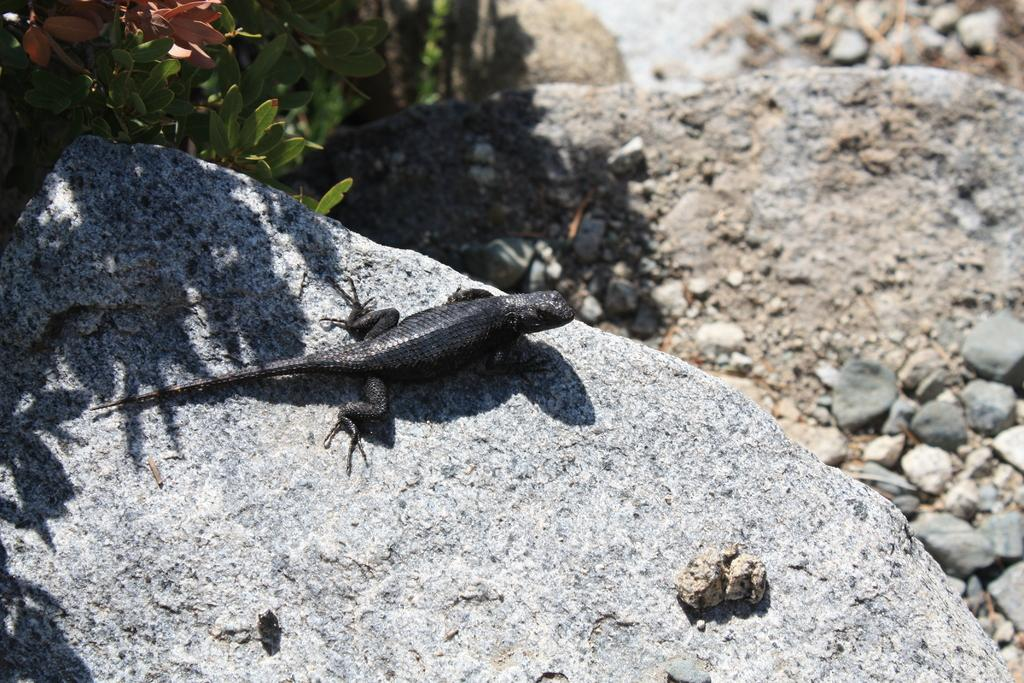What type of animal is in the image? There is a reptile in the image. Where is the reptile located? The reptile is on a rock. What is the color of the reptile? The reptile is black in color. What can be seen on the right side of the image? There are stones on the right side of the image. What type of vegetation is on the left side of the image? There are plants on the left side of the image. What advice does the reptile's aunt give during their discussion in the image? There is no mention of an aunt or a discussion in the image; it only features a reptile on a rock with stones and plants nearby. 